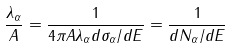Convert formula to latex. <formula><loc_0><loc_0><loc_500><loc_500>\frac { \lambda _ { \alpha } } { A } = \frac { 1 } { 4 \pi A \lambda _ { \alpha } d \sigma _ { \alpha } / d E } = \frac { 1 } { d N _ { \alpha } / d E }</formula> 